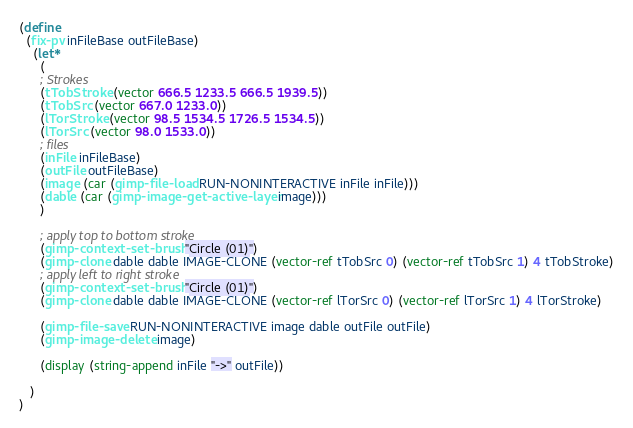<code> <loc_0><loc_0><loc_500><loc_500><_Scheme_>
(define 
  (fix-pv inFileBase outFileBase)
    (let* 
      (
      ; Strokes
      (tTobStroke (vector 666.5 1233.5 666.5 1939.5))
      (tTobSrc (vector 667.0 1233.0))
      (lTorStroke (vector 98.5 1534.5 1726.5 1534.5))
      (lTorSrc (vector 98.0 1533.0))
      ; files
      (inFile inFileBase)
      (outFile outFileBase)
      (image (car (gimp-file-load RUN-NONINTERACTIVE inFile inFile)))
      (dable (car (gimp-image-get-active-layer image)))
      )

      ; apply top to bottom stroke
      (gimp-context-set-brush "Circle (01)")
      (gimp-clone dable dable IMAGE-CLONE (vector-ref tTobSrc 0) (vector-ref tTobSrc 1) 4 tTobStroke)
      ; apply left to right stroke
      (gimp-context-set-brush "Circle (01)")
      (gimp-clone dable dable IMAGE-CLONE (vector-ref lTorSrc 0) (vector-ref lTorSrc 1) 4 lTorStroke)

      (gimp-file-save RUN-NONINTERACTIVE image dable outFile outFile)
      (gimp-image-delete image)

      (display (string-append inFile "->" outFile))

   )
)

</code> 